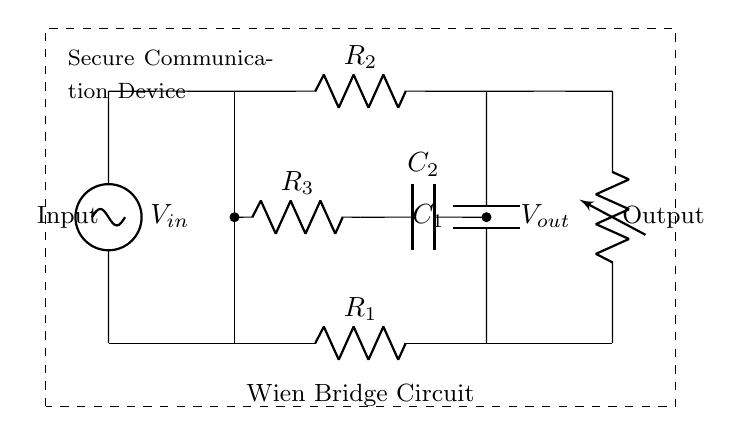What type of circuit is this? This circuit is a Wien bridge circuit, known for its use in frequency response analysis due to the arrangement of resistors and capacitors that allow for the generation of sinusoidal voltages.
Answer: Wien bridge Which components are present in the circuit? The circuit contains resistors R1, R2, R3 and capacitors C1, C2, in addition to input and output voltage sources.
Answer: R1, R2, R3, C1, C2 What is the role of C1 in this circuit? Capacitor C1 is part of the bridge configuration, influencing frequency response and phase shift, which is crucial for accurate signal processing.
Answer: Frequency response How are R3 and C2 connected? Resistor R3 and capacitor C2 are connected in parallel, allowing the circuit to alter its impedance at different frequencies, affecting output signal characteristics.
Answer: In parallel What is the purpose of the input voltage \( V_{in} \)? The input voltage \( V_{in} \) serves as the excitation signal for the circuit, which is analyzed to understand the frequency response characteristics of the device.
Answer: Excitation signal What happens if R1 and R2 are equal? If R1 and R2 are equal, the bridge becomes balanced, leading to zero voltage at the output, which simplifies measurements for frequency response analysis.
Answer: Zero output voltage 